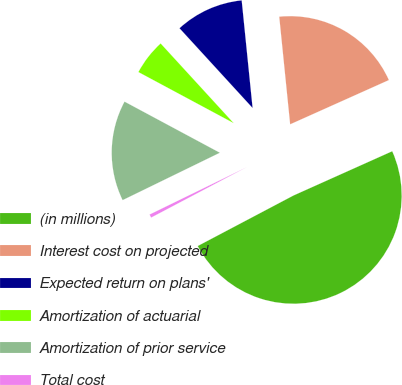Convert chart to OTSL. <chart><loc_0><loc_0><loc_500><loc_500><pie_chart><fcel>(in millions)<fcel>Interest cost on projected<fcel>Expected return on plans'<fcel>Amortization of actuarial<fcel>Amortization of prior service<fcel>Total cost<nl><fcel>48.98%<fcel>19.9%<fcel>10.2%<fcel>5.36%<fcel>15.05%<fcel>0.51%<nl></chart> 